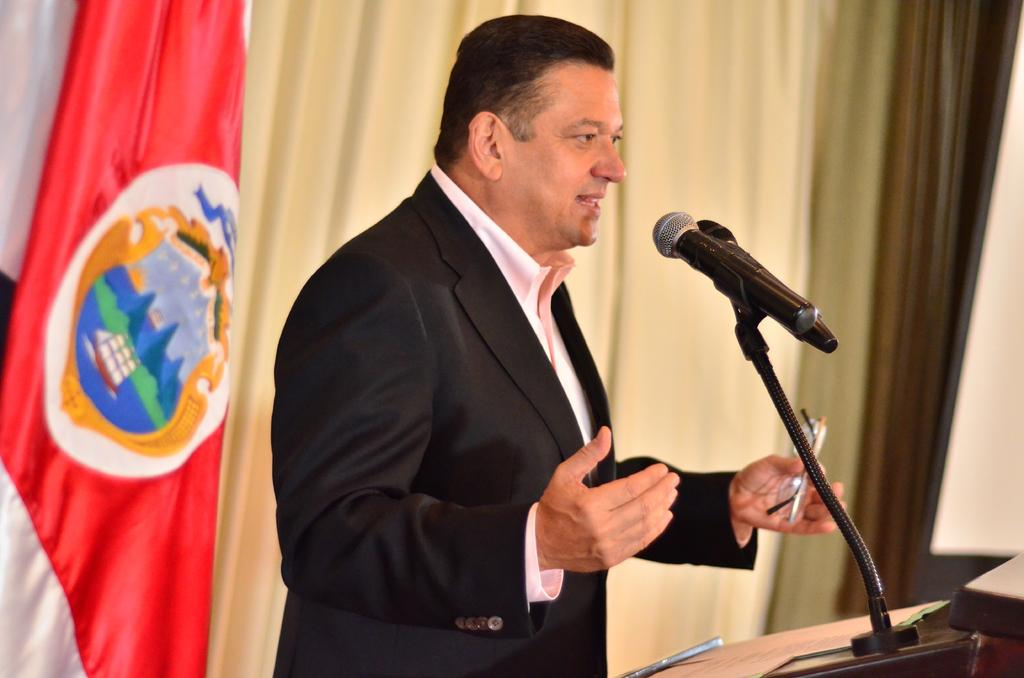Who or what is the main subject in the image? There is a person in the image. What is the person holding in the image? The person is holding a spectacle. Where is the person standing in the image? The person is standing in front of a podium. What is on the podium? There is a book and a microphone on the podium. What can be seen behind the person? Colorful curtains are visible behind the person. What type of government is being discussed in the image? There is no discussion of government in the image; it features a person holding a spectacle and standing in front of a podium with a book and microphone. What type of produce is being sold on the desk in the image? There is no desk or produce present in the image. 